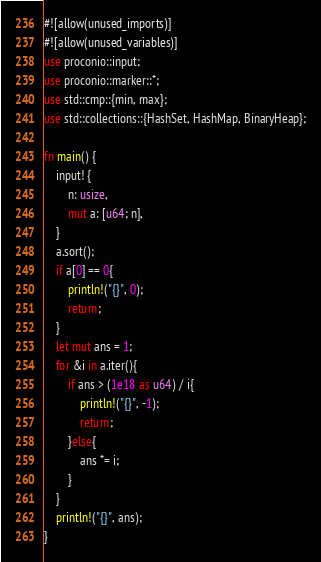Convert code to text. <code><loc_0><loc_0><loc_500><loc_500><_Rust_>#![allow(unused_imports)]
#![allow(unused_variables)]
use proconio::input;
use proconio::marker::*;
use std::cmp::{min, max};
use std::collections::{HashSet, HashMap, BinaryHeap};

fn main() {
    input! {
        n: usize,
        mut a: [u64; n],
    }
    a.sort();
    if a[0] == 0{
        println!("{}", 0);
        return;
    }
    let mut ans = 1;
    for &i in a.iter(){
        if ans > (1e18 as u64) / i{
            println!("{}", -1);
            return;
        }else{
            ans *= i;
        }
    }
    println!("{}", ans);
}
</code> 